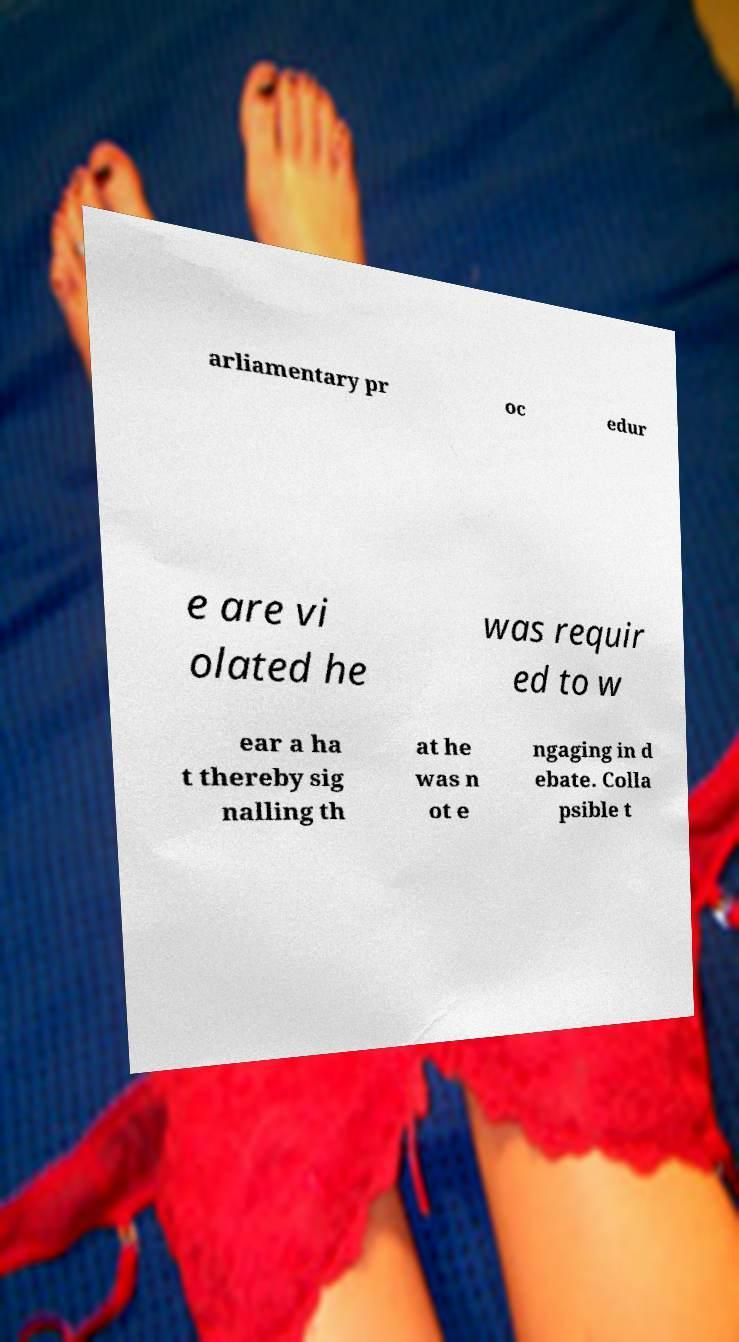Please identify and transcribe the text found in this image. arliamentary pr oc edur e are vi olated he was requir ed to w ear a ha t thereby sig nalling th at he was n ot e ngaging in d ebate. Colla psible t 